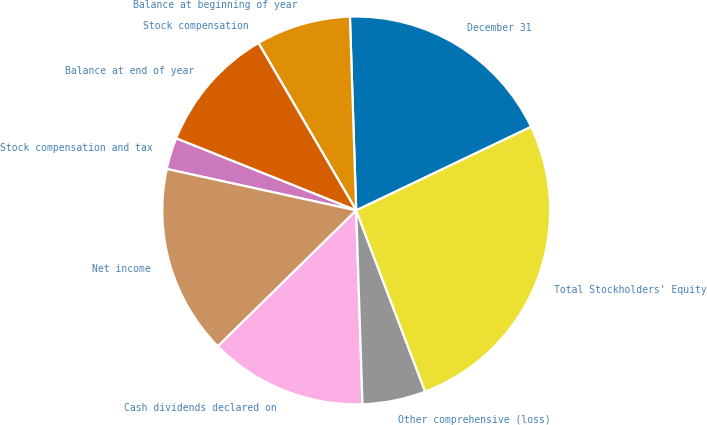Convert chart. <chart><loc_0><loc_0><loc_500><loc_500><pie_chart><fcel>December 31<fcel>Balance at beginning of year<fcel>Stock compensation<fcel>Balance at end of year<fcel>Stock compensation and tax<fcel>Net income<fcel>Cash dividends declared on<fcel>Other comprehensive (loss)<fcel>Total Stockholders' Equity<nl><fcel>18.42%<fcel>7.9%<fcel>0.0%<fcel>10.53%<fcel>2.63%<fcel>15.79%<fcel>13.16%<fcel>5.27%<fcel>26.31%<nl></chart> 